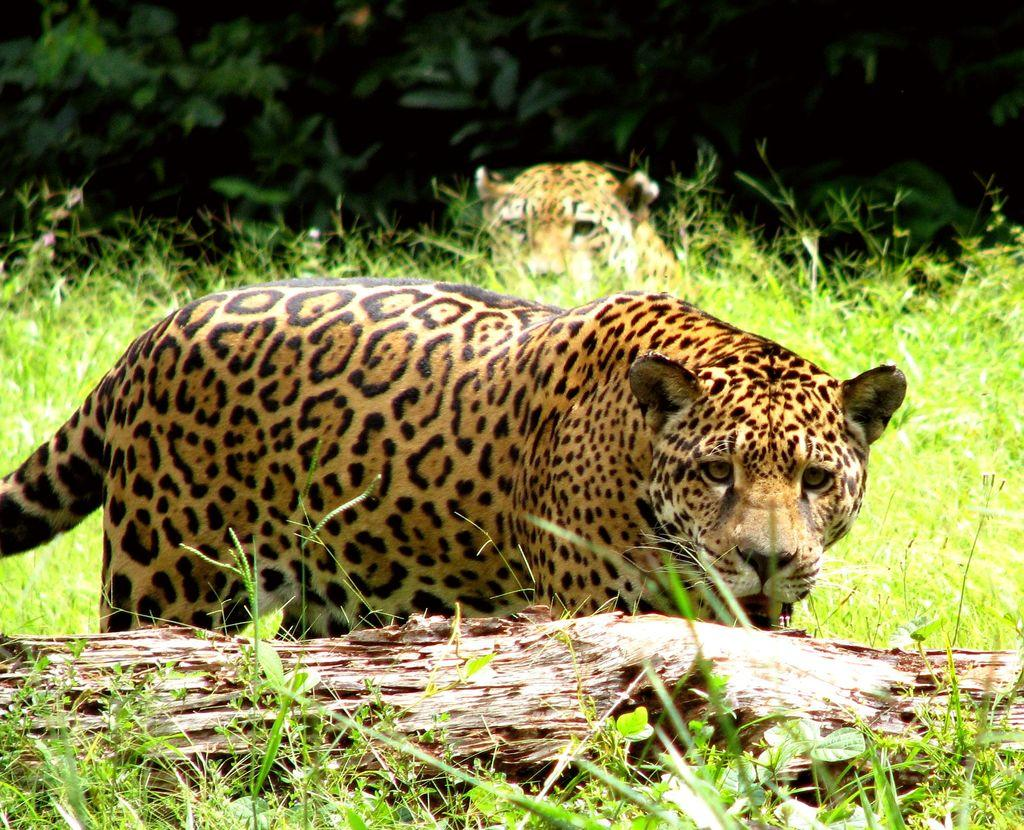What type of vegetation can be seen in the background of the image? There are green leaves in the background of the image. What animals are present in the image? There are leopards in the image. What type of ground surface is visible in the image? There is grass in the image. What other types of vegetation can be seen in the image? There are plants in the image. What object is present in the image that is related to a tree? There is a branch in the image. Can you measure the distance between the leopards and the seashore in the image? There is no seashore present in the image, so it is not possible to measure the distance between the leopards and the seashore. Is there a ship visible in the image? There is no ship present in the image. 